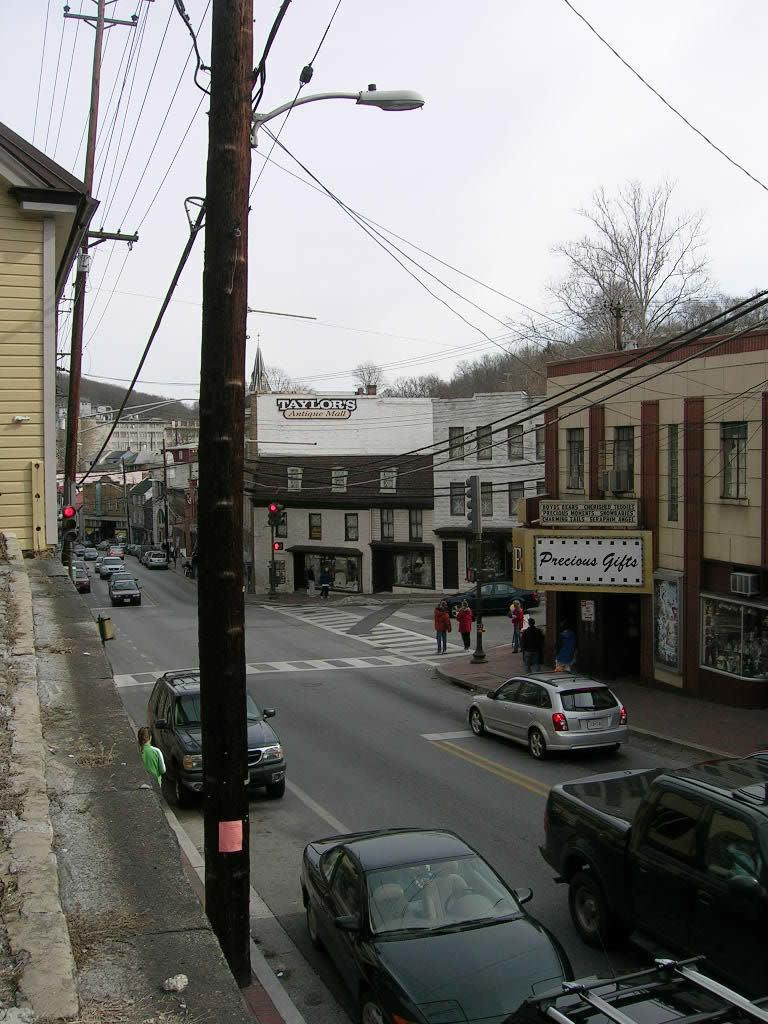What structures are present in the image? There are poles in the image. What type of vehicles can be seen on the road in the image? There are cars on the road in the image. What can be seen in the background of the image? There are buildings, trees, and posters in the background of the image. What color are the eyes of the person holding the scissors in the image? There are no people or scissors present in the image. 